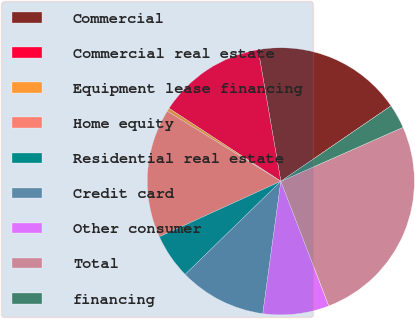<chart> <loc_0><loc_0><loc_500><loc_500><pie_chart><fcel>Commercial<fcel>Commercial real estate<fcel>Equipment lease financing<fcel>Home equity<fcel>Residential real estate<fcel>Credit card<fcel>Other consumer<fcel>Total<fcel>financing<nl><fcel>18.16%<fcel>13.08%<fcel>0.4%<fcel>15.62%<fcel>5.47%<fcel>10.55%<fcel>8.01%<fcel>25.77%<fcel>2.94%<nl></chart> 